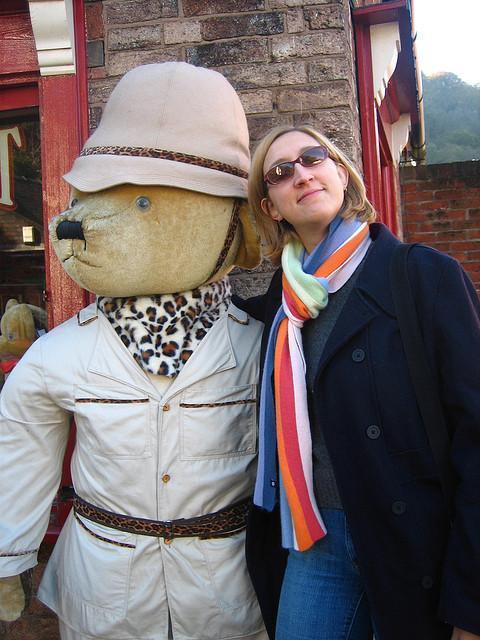How many teddy bears can be seen?
Give a very brief answer. 2. How many carrots are on top of the cartoon image?
Give a very brief answer. 0. 